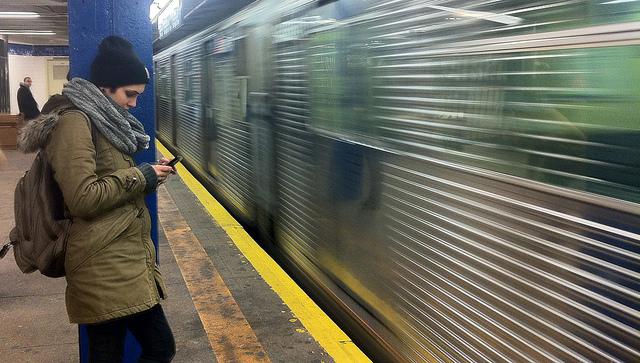What is the yellow line on the floor for?
Concise answer only. Safety. Has the train stopped?
Short answer required. No. What color is the man's scarf?
Concise answer only. Gray. What type of transit is shown in this picture?
Keep it brief. Subway. 